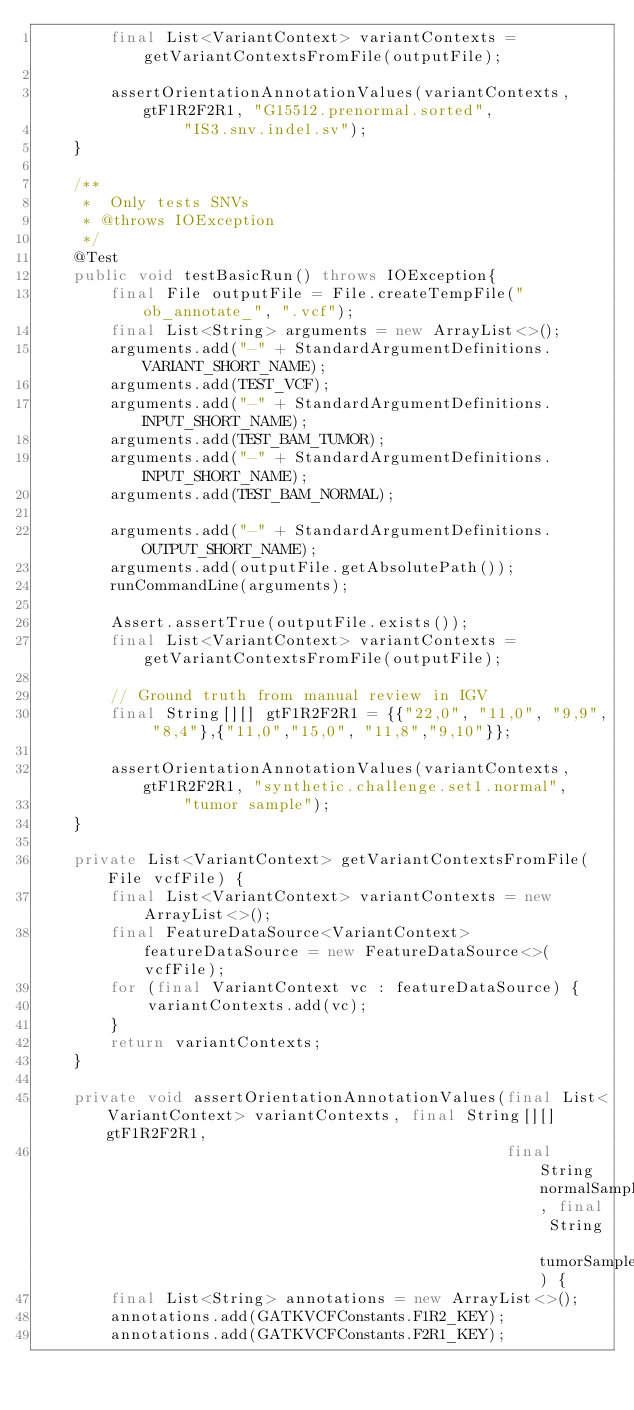Convert code to text. <code><loc_0><loc_0><loc_500><loc_500><_Java_>        final List<VariantContext> variantContexts = getVariantContextsFromFile(outputFile);

        assertOrientationAnnotationValues(variantContexts, gtF1R2F2R1, "G15512.prenormal.sorted",
                "IS3.snv.indel.sv");
    }

    /**
     *  Only tests SNVs
     * @throws IOException
     */
    @Test
    public void testBasicRun() throws IOException{
        final File outputFile = File.createTempFile("ob_annotate_", ".vcf");
        final List<String> arguments = new ArrayList<>();
        arguments.add("-" + StandardArgumentDefinitions.VARIANT_SHORT_NAME);
        arguments.add(TEST_VCF);
        arguments.add("-" + StandardArgumentDefinitions.INPUT_SHORT_NAME);
        arguments.add(TEST_BAM_TUMOR);
        arguments.add("-" + StandardArgumentDefinitions.INPUT_SHORT_NAME);
        arguments.add(TEST_BAM_NORMAL);

        arguments.add("-" + StandardArgumentDefinitions.OUTPUT_SHORT_NAME);
        arguments.add(outputFile.getAbsolutePath());
        runCommandLine(arguments);

        Assert.assertTrue(outputFile.exists());
        final List<VariantContext> variantContexts = getVariantContextsFromFile(outputFile);

        // Ground truth from manual review in IGV
        final String[][] gtF1R2F2R1 = {{"22,0", "11,0", "9,9", "8,4"},{"11,0","15,0", "11,8","9,10"}};

        assertOrientationAnnotationValues(variantContexts, gtF1R2F2R1, "synthetic.challenge.set1.normal",
                "tumor sample");
    }

    private List<VariantContext> getVariantContextsFromFile(File vcfFile) {
        final List<VariantContext> variantContexts = new ArrayList<>();
        final FeatureDataSource<VariantContext> featureDataSource = new FeatureDataSource<>(vcfFile);
        for (final VariantContext vc : featureDataSource) {
            variantContexts.add(vc);
        }
        return variantContexts;
    }

    private void assertOrientationAnnotationValues(final List<VariantContext> variantContexts, final String[][] gtF1R2F2R1,
                                                   final String normalSampleName, final String tumorSampleName) {
        final List<String> annotations = new ArrayList<>();
        annotations.add(GATKVCFConstants.F1R2_KEY);
        annotations.add(GATKVCFConstants.F2R1_KEY);
</code> 